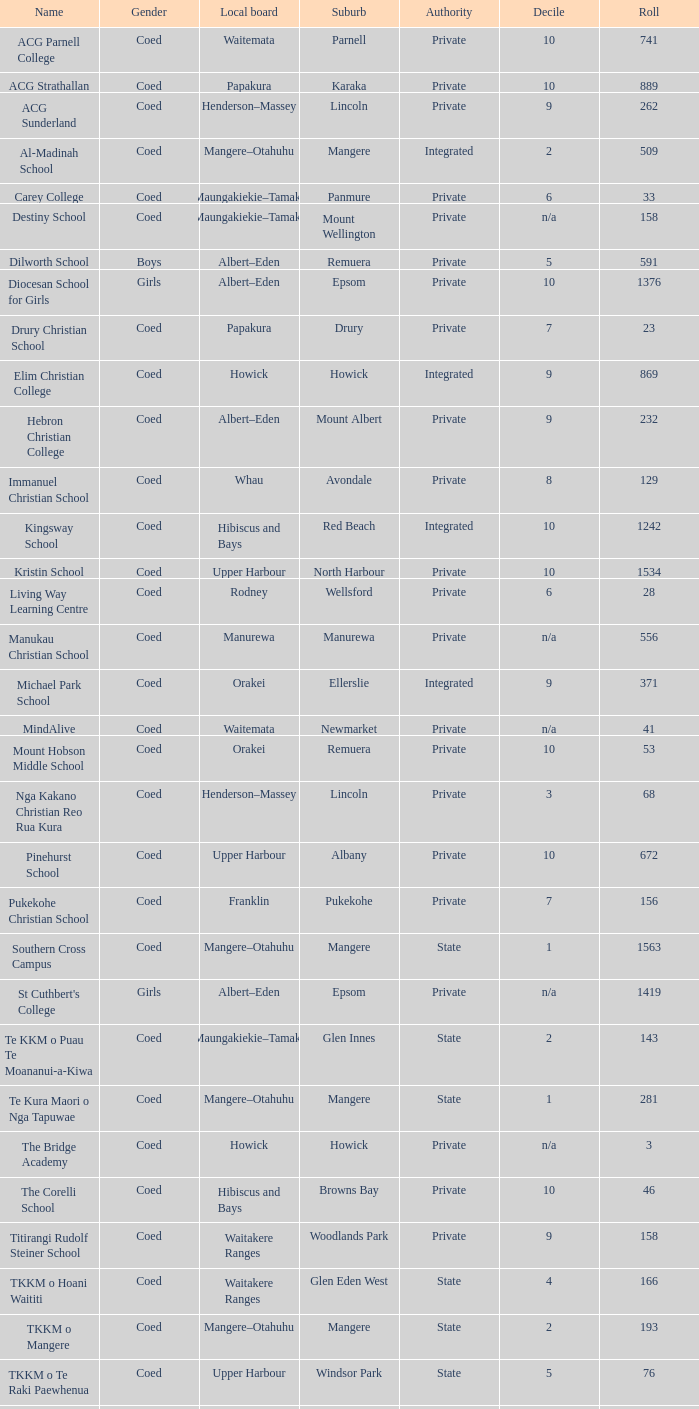Write the full table. {'header': ['Name', 'Gender', 'Local board', 'Suburb', 'Authority', 'Decile', 'Roll'], 'rows': [['ACG Parnell College', 'Coed', 'Waitemata', 'Parnell', 'Private', '10', '741'], ['ACG Strathallan', 'Coed', 'Papakura', 'Karaka', 'Private', '10', '889'], ['ACG Sunderland', 'Coed', 'Henderson–Massey', 'Lincoln', 'Private', '9', '262'], ['Al-Madinah School', 'Coed', 'Mangere–Otahuhu', 'Mangere', 'Integrated', '2', '509'], ['Carey College', 'Coed', 'Maungakiekie–Tamaki', 'Panmure', 'Private', '6', '33'], ['Destiny School', 'Coed', 'Maungakiekie–Tamaki', 'Mount Wellington', 'Private', 'n/a', '158'], ['Dilworth School', 'Boys', 'Albert–Eden', 'Remuera', 'Private', '5', '591'], ['Diocesan School for Girls', 'Girls', 'Albert–Eden', 'Epsom', 'Private', '10', '1376'], ['Drury Christian School', 'Coed', 'Papakura', 'Drury', 'Private', '7', '23'], ['Elim Christian College', 'Coed', 'Howick', 'Howick', 'Integrated', '9', '869'], ['Hebron Christian College', 'Coed', 'Albert–Eden', 'Mount Albert', 'Private', '9', '232'], ['Immanuel Christian School', 'Coed', 'Whau', 'Avondale', 'Private', '8', '129'], ['Kingsway School', 'Coed', 'Hibiscus and Bays', 'Red Beach', 'Integrated', '10', '1242'], ['Kristin School', 'Coed', 'Upper Harbour', 'North Harbour', 'Private', '10', '1534'], ['Living Way Learning Centre', 'Coed', 'Rodney', 'Wellsford', 'Private', '6', '28'], ['Manukau Christian School', 'Coed', 'Manurewa', 'Manurewa', 'Private', 'n/a', '556'], ['Michael Park School', 'Coed', 'Orakei', 'Ellerslie', 'Integrated', '9', '371'], ['MindAlive', 'Coed', 'Waitemata', 'Newmarket', 'Private', 'n/a', '41'], ['Mount Hobson Middle School', 'Coed', 'Orakei', 'Remuera', 'Private', '10', '53'], ['Nga Kakano Christian Reo Rua Kura', 'Coed', 'Henderson–Massey', 'Lincoln', 'Private', '3', '68'], ['Pinehurst School', 'Coed', 'Upper Harbour', 'Albany', 'Private', '10', '672'], ['Pukekohe Christian School', 'Coed', 'Franklin', 'Pukekohe', 'Private', '7', '156'], ['Southern Cross Campus', 'Coed', 'Mangere–Otahuhu', 'Mangere', 'State', '1', '1563'], ["St Cuthbert's College", 'Girls', 'Albert–Eden', 'Epsom', 'Private', 'n/a', '1419'], ['Te KKM o Puau Te Moananui-a-Kiwa', 'Coed', 'Maungakiekie–Tamaki', 'Glen Innes', 'State', '2', '143'], ['Te Kura Maori o Nga Tapuwae', 'Coed', 'Mangere–Otahuhu', 'Mangere', 'State', '1', '281'], ['The Bridge Academy', 'Coed', 'Howick', 'Howick', 'Private', 'n/a', '3'], ['The Corelli School', 'Coed', 'Hibiscus and Bays', 'Browns Bay', 'Private', '10', '46'], ['Titirangi Rudolf Steiner School', 'Coed', 'Waitakere Ranges', 'Woodlands Park', 'Private', '9', '158'], ['TKKM o Hoani Waititi', 'Coed', 'Waitakere Ranges', 'Glen Eden West', 'State', '4', '166'], ['TKKM o Mangere', 'Coed', 'Mangere–Otahuhu', 'Mangere', 'State', '2', '193'], ['TKKM o Te Raki Paewhenua', 'Coed', 'Upper Harbour', 'Windsor Park', 'State', '5', '76'], ['Tyndale Park Christian School', 'Coed', 'Howick', 'Flat Bush', 'Private', 'n/a', '120']]} What gender is present in a local albert-eden committee with a roll above 232 and a 5 decile? Boys. 